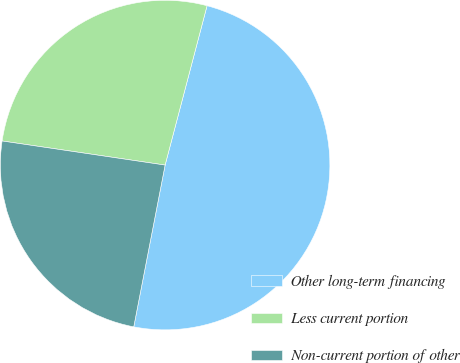<chart> <loc_0><loc_0><loc_500><loc_500><pie_chart><fcel>Other long-term financing<fcel>Less current portion<fcel>Non-current portion of other<nl><fcel>48.95%<fcel>26.76%<fcel>24.29%<nl></chart> 